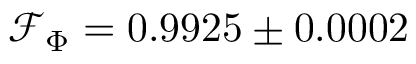<formula> <loc_0><loc_0><loc_500><loc_500>\mathcal { F } _ { \Phi } = 0 . 9 9 2 5 \pm 0 . 0 0 0 2</formula> 